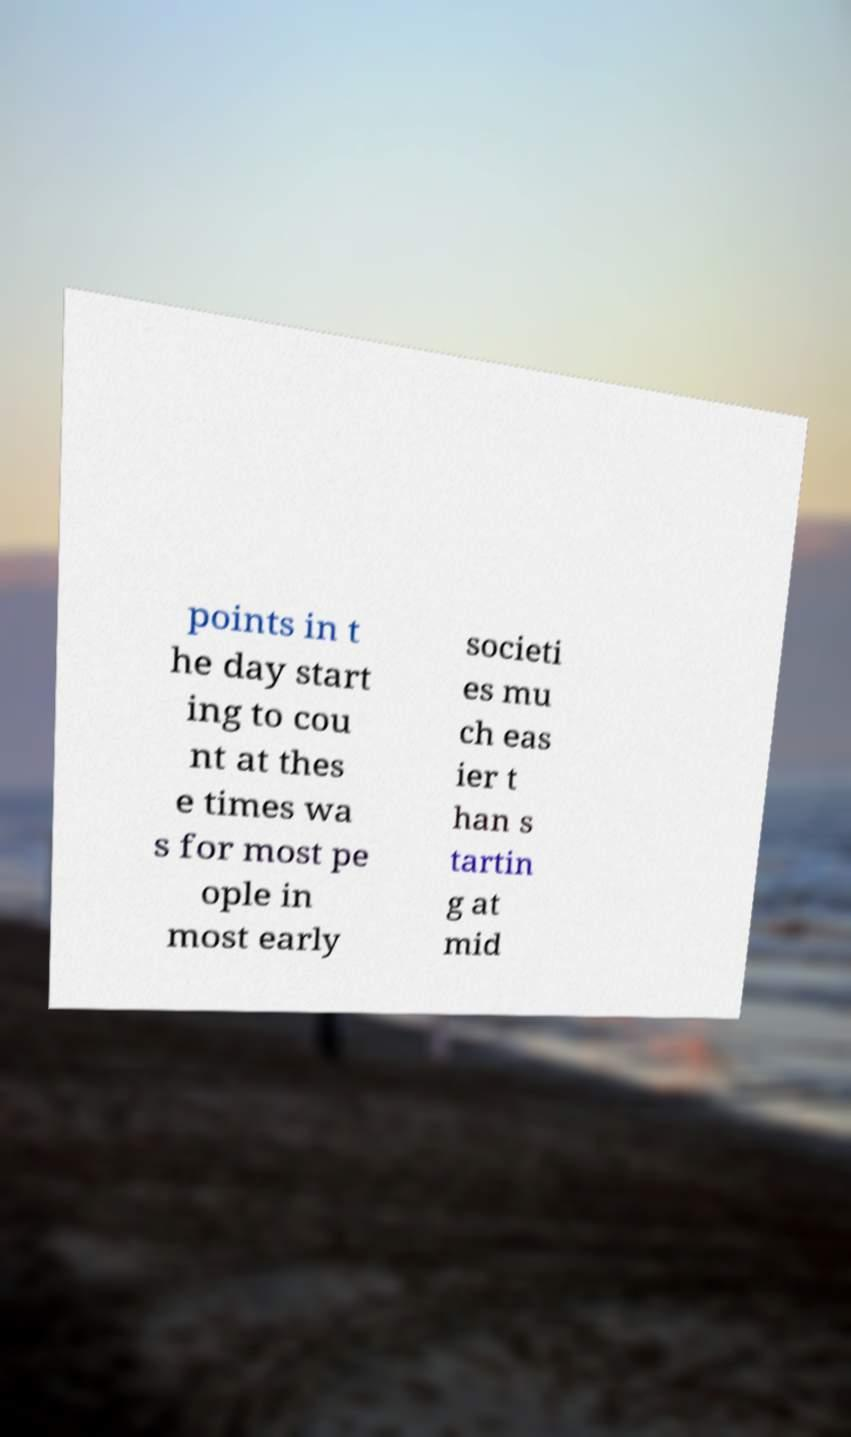Could you assist in decoding the text presented in this image and type it out clearly? points in t he day start ing to cou nt at thes e times wa s for most pe ople in most early societi es mu ch eas ier t han s tartin g at mid 